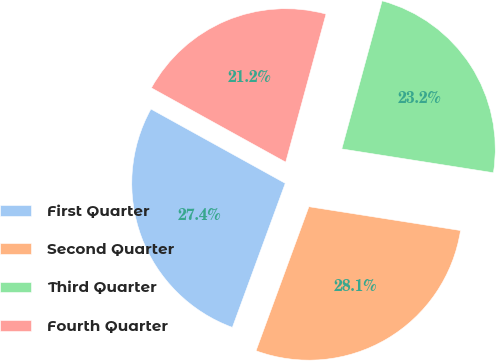Convert chart to OTSL. <chart><loc_0><loc_0><loc_500><loc_500><pie_chart><fcel>First Quarter<fcel>Second Quarter<fcel>Third Quarter<fcel>Fourth Quarter<nl><fcel>27.44%<fcel>28.12%<fcel>23.25%<fcel>21.19%<nl></chart> 